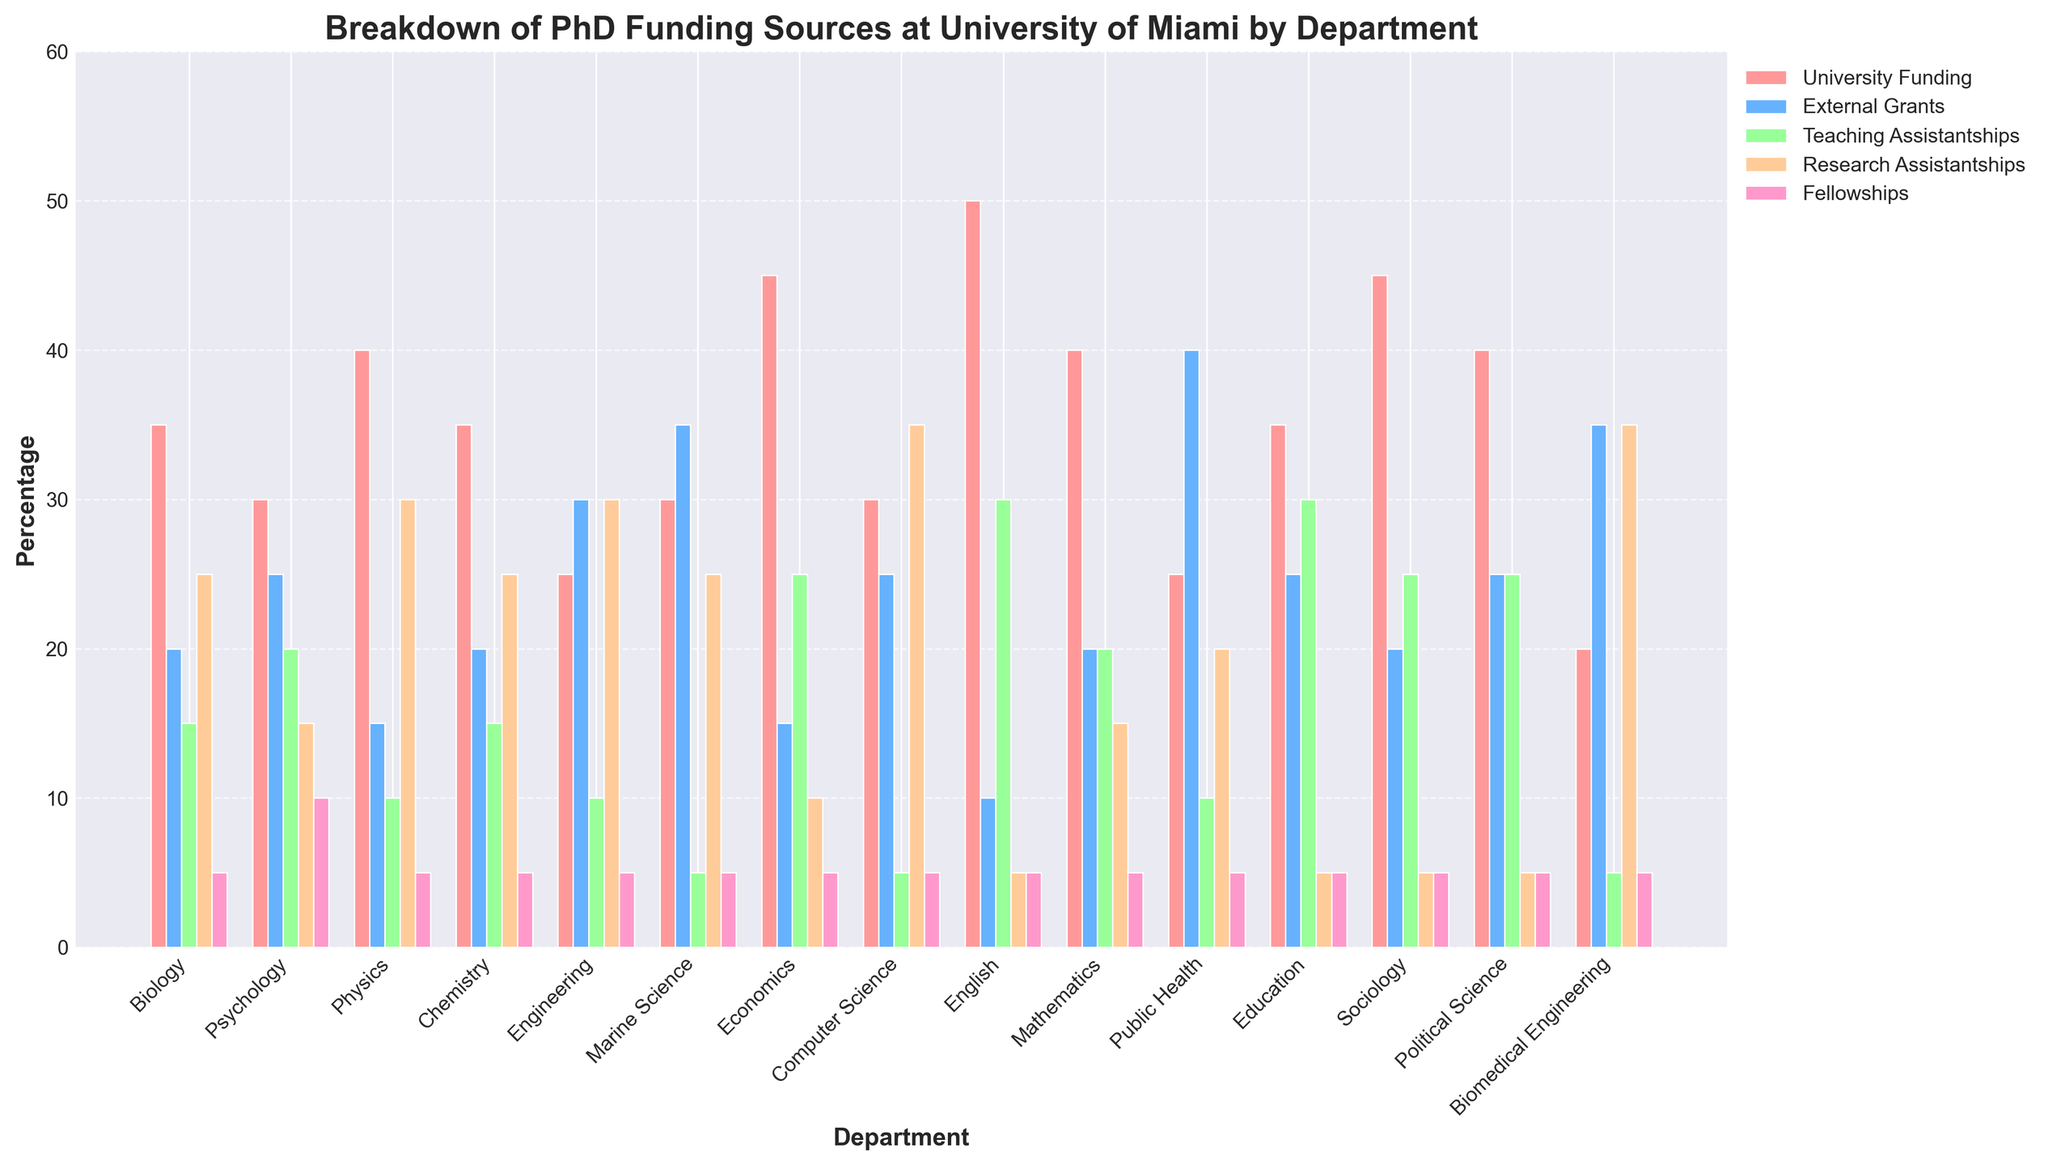Which department has the highest percentage of Teaching Assistantships? Look at the Teaching Assistantships category (green bars) and identify the highest bar. The department with the highest percentage is English, as it has the tallest green bar.
Answer: English What is the combined percentage of Research Assistantships and Fellowships in Biomedical Engineering? Add the percentage of Research Assistantships (35) and Fellowships (5) in Biomedical Engineering. The sum is 35 + 5 = 40.
Answer: 40 Which two departments have the same percentage of University Funding? Compare the University Funding percentages (red bars) across all departments. Psychology and Chemistry both have a percentage of 35.
Answer: Psychology, Chemistry How much higher is the percentage of External Grants in Public Health compared to Biology? Subtract the percentage of External Grants in Biology (20) from that in Public Health (40). The difference is 40 - 20 = 20.
Answer: 20 Which funding source is the most evenly distributed across all departments? Visually inspect the consistency of bar heights among the different funding sources. Fellowship bars (purple) appear to be the most consistent across departments.
Answer: Fellowships In which department is University Funding more than the sum of Teaching and Research Assistantships? Compare University Funding with the combined values of Teaching (green) and Research Assistantships (orange) in each department. For Economics, University Funding (45) is more than Teaching (25) + Research Assistantships (10), which totals 35.
Answer: Economics What is the average percentage of External Grants across all departments? Sum the External Grants percentages for all 15 departments (20 + 25 + 15 + 20 + 30 + 35 + 15 + 25 + 10 + 20 + 40 + 25 + 20 + 25 + 35) which equals 360. Divide by the number of departments (15). The average is 360 / 15 = 24.
Answer: 24 Which department has the lowest percentage of External Grants but a high percentage of Research Assistantships? Look for the department with the lowest External Grants (blue bars) and then compare with the heights of the Research Assistantships bars (orange). Computer Science has only 5 percent in External Grants but 35 percent in Research Assistantships.
Answer: Computer Science 